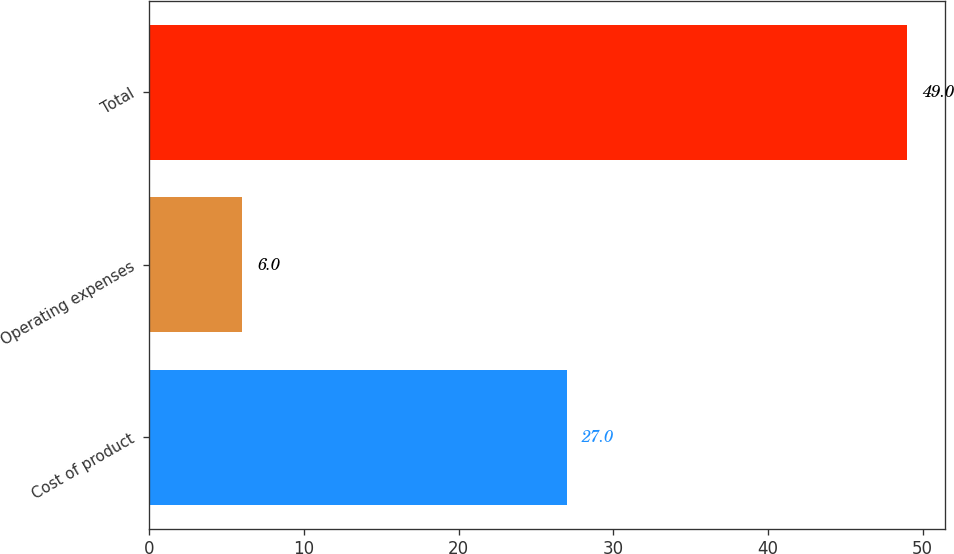Convert chart. <chart><loc_0><loc_0><loc_500><loc_500><bar_chart><fcel>Cost of product<fcel>Operating expenses<fcel>Total<nl><fcel>27<fcel>6<fcel>49<nl></chart> 